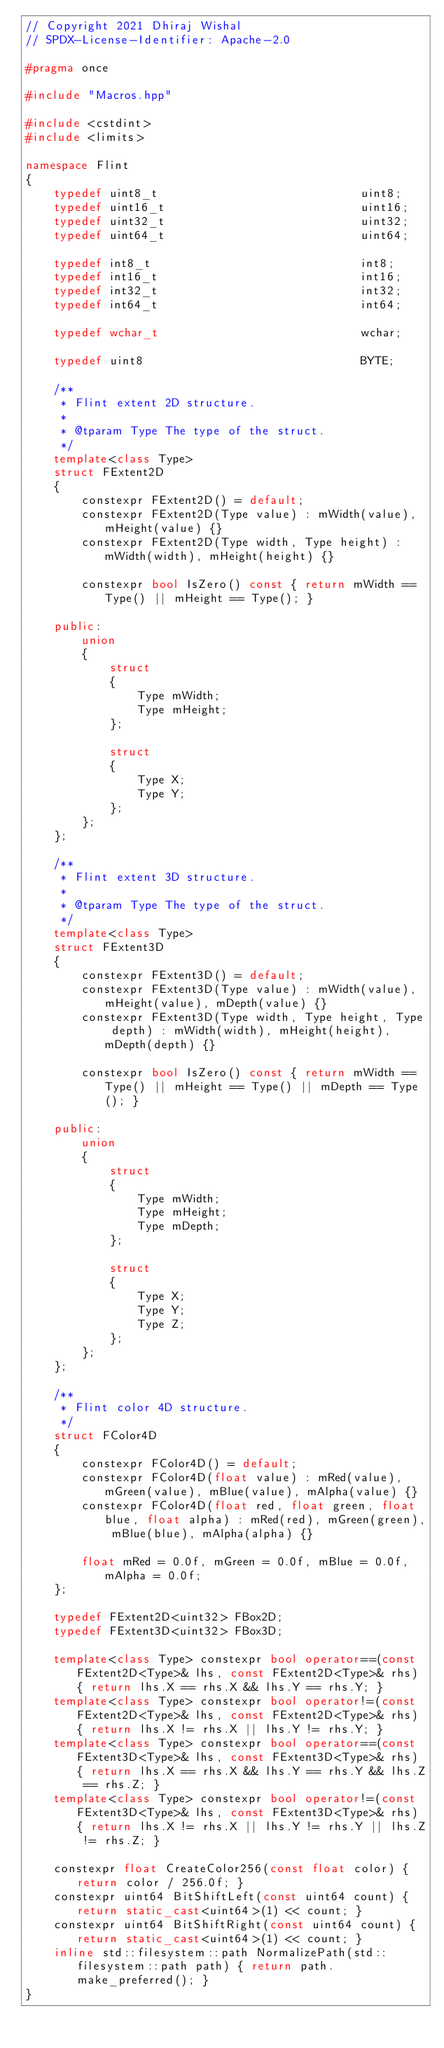<code> <loc_0><loc_0><loc_500><loc_500><_C++_>// Copyright 2021 Dhiraj Wishal
// SPDX-License-Identifier: Apache-2.0

#pragma once

#include "Macros.hpp"

#include <cstdint>
#include <limits>

namespace Flint
{
	typedef uint8_t								uint8;
	typedef uint16_t							uint16;
	typedef uint32_t							uint32;
	typedef uint64_t							uint64;

	typedef int8_t								int8;
	typedef int16_t								int16;
	typedef int32_t								int32;
	typedef int64_t								int64;

	typedef wchar_t								wchar;

	typedef uint8								BYTE;

	/**
	 * Flint extent 2D structure.
	 *
	 * @tparam Type The type of the struct.
	 */
	template<class Type>
	struct FExtent2D
	{
		constexpr FExtent2D() = default;
		constexpr FExtent2D(Type value) : mWidth(value), mHeight(value) {}
		constexpr FExtent2D(Type width, Type height) : mWidth(width), mHeight(height) {}

		constexpr bool IsZero() const { return mWidth == Type() || mHeight == Type(); }

	public:
		union
		{
			struct
			{
				Type mWidth;
				Type mHeight;
			};

			struct
			{
				Type X;
				Type Y;
			};
		};
	};

	/**
	 * Flint extent 3D structure.
	 *
	 * @tparam Type The type of the struct.
	 */
	template<class Type>
	struct FExtent3D
	{
		constexpr FExtent3D() = default;
		constexpr FExtent3D(Type value) : mWidth(value), mHeight(value), mDepth(value) {}
		constexpr FExtent3D(Type width, Type height, Type depth) : mWidth(width), mHeight(height), mDepth(depth) {}

		constexpr bool IsZero() const { return mWidth == Type() || mHeight == Type() || mDepth == Type(); }

	public:
		union
		{
			struct
			{
				Type mWidth;
				Type mHeight;
				Type mDepth;
			};

			struct
			{
				Type X;
				Type Y;
				Type Z;
			};
		};
	};

	/**
	 * Flint color 4D structure.
	 */
	struct FColor4D
	{
		constexpr FColor4D() = default;
		constexpr FColor4D(float value) : mRed(value), mGreen(value), mBlue(value), mAlpha(value) {}
		constexpr FColor4D(float red, float green, float blue, float alpha) : mRed(red), mGreen(green), mBlue(blue), mAlpha(alpha) {}

		float mRed = 0.0f, mGreen = 0.0f, mBlue = 0.0f, mAlpha = 0.0f;
	};

	typedef FExtent2D<uint32> FBox2D;
	typedef FExtent3D<uint32> FBox3D;

	template<class Type> constexpr bool operator==(const FExtent2D<Type>& lhs, const FExtent2D<Type>& rhs) { return lhs.X == rhs.X && lhs.Y == rhs.Y; }
	template<class Type> constexpr bool operator!=(const FExtent2D<Type>& lhs, const FExtent2D<Type>& rhs) { return lhs.X != rhs.X || lhs.Y != rhs.Y; }
	template<class Type> constexpr bool operator==(const FExtent3D<Type>& lhs, const FExtent3D<Type>& rhs) { return lhs.X == rhs.X && lhs.Y == rhs.Y && lhs.Z == rhs.Z; }
	template<class Type> constexpr bool operator!=(const FExtent3D<Type>& lhs, const FExtent3D<Type>& rhs) { return lhs.X != rhs.X || lhs.Y != rhs.Y || lhs.Z != rhs.Z; }

	constexpr float CreateColor256(const float color) { return color / 256.0f; }
	constexpr uint64 BitShiftLeft(const uint64 count) { return static_cast<uint64>(1) << count; }
	constexpr uint64 BitShiftRight(const uint64 count) { return static_cast<uint64>(1) << count; }
	inline std::filesystem::path NormalizePath(std::filesystem::path path) { return path.make_preferred(); }
}</code> 